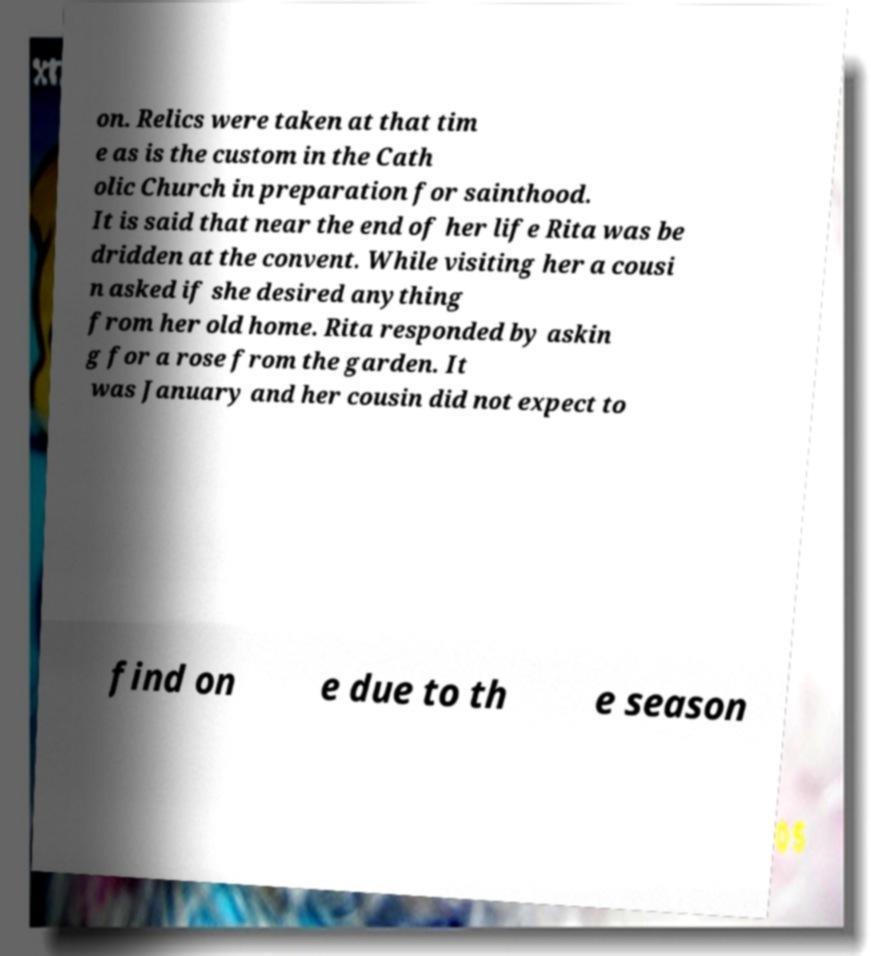I need the written content from this picture converted into text. Can you do that? on. Relics were taken at that tim e as is the custom in the Cath olic Church in preparation for sainthood. It is said that near the end of her life Rita was be dridden at the convent. While visiting her a cousi n asked if she desired anything from her old home. Rita responded by askin g for a rose from the garden. It was January and her cousin did not expect to find on e due to th e season 